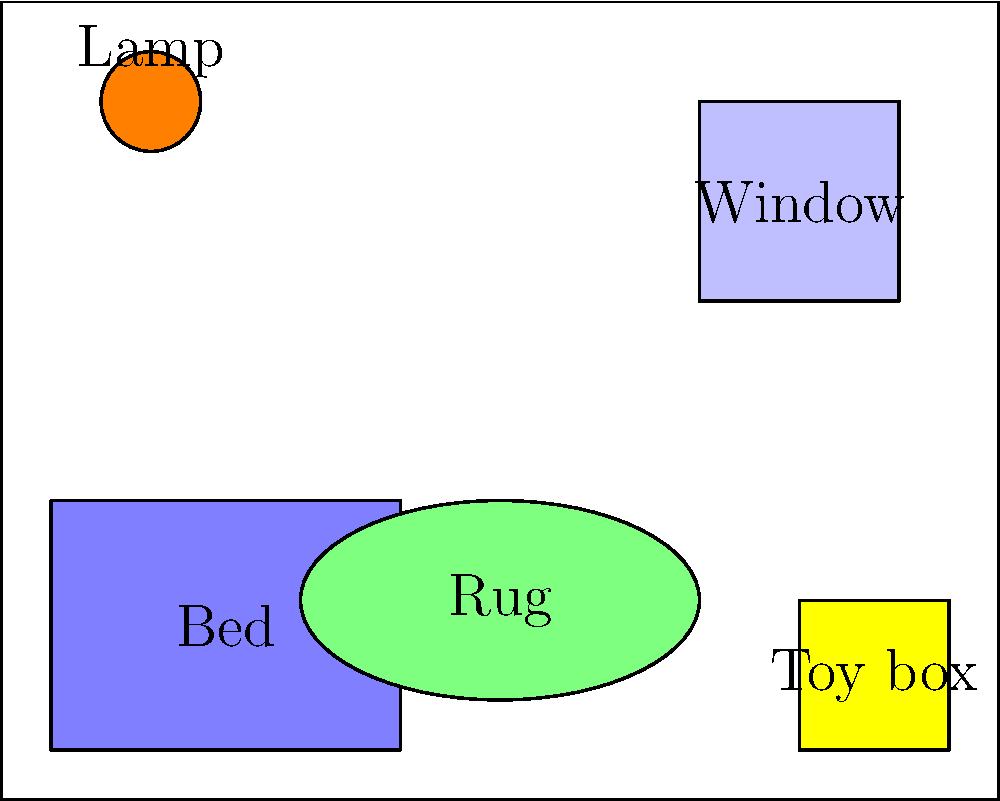In this cartoon scene of a child's bedroom, how many different geometric shapes can you identify? List them and provide an example of each shape from the image. Let's identify the geometric shapes in the cartoon scene:

1. Rectangle: There are several rectangles in the image.
   - The room outline
   - The bed
   - The window
   - The toy box

2. Circle: There is one clear circle in the image.
   - The lamp shade

3. Ellipse: There is one ellipse in the image.
   - The rug on the floor

To summarize:
- Rectangles: 4 (room, bed, window, toy box)
- Circle: 1 (lamp shade)
- Ellipse: 1 (rug)

Therefore, we can identify 3 different geometric shapes in this cartoon scene of a child's bedroom.
Answer: 3 shapes: Rectangle (room), Circle (lamp), Ellipse (rug) 